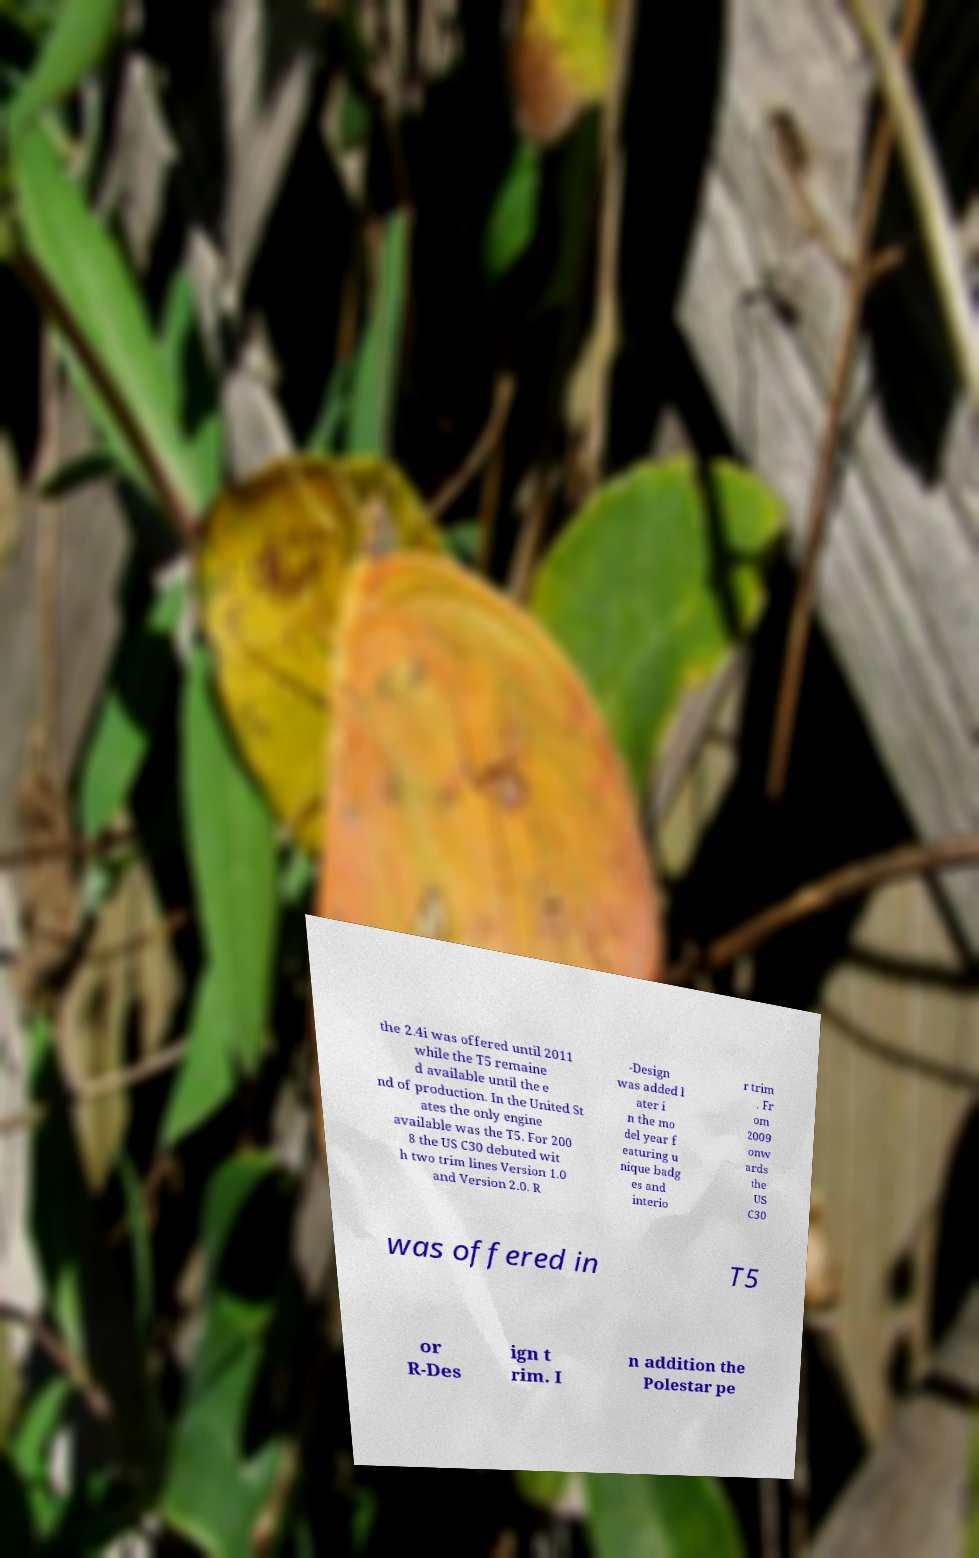Could you extract and type out the text from this image? the 2.4i was offered until 2011 while the T5 remaine d available until the e nd of production. In the United St ates the only engine available was the T5. For 200 8 the US C30 debuted wit h two trim lines Version 1.0 and Version 2.0. R -Design was added l ater i n the mo del year f eaturing u nique badg es and interio r trim . Fr om 2009 onw ards the US C30 was offered in T5 or R-Des ign t rim. I n addition the Polestar pe 